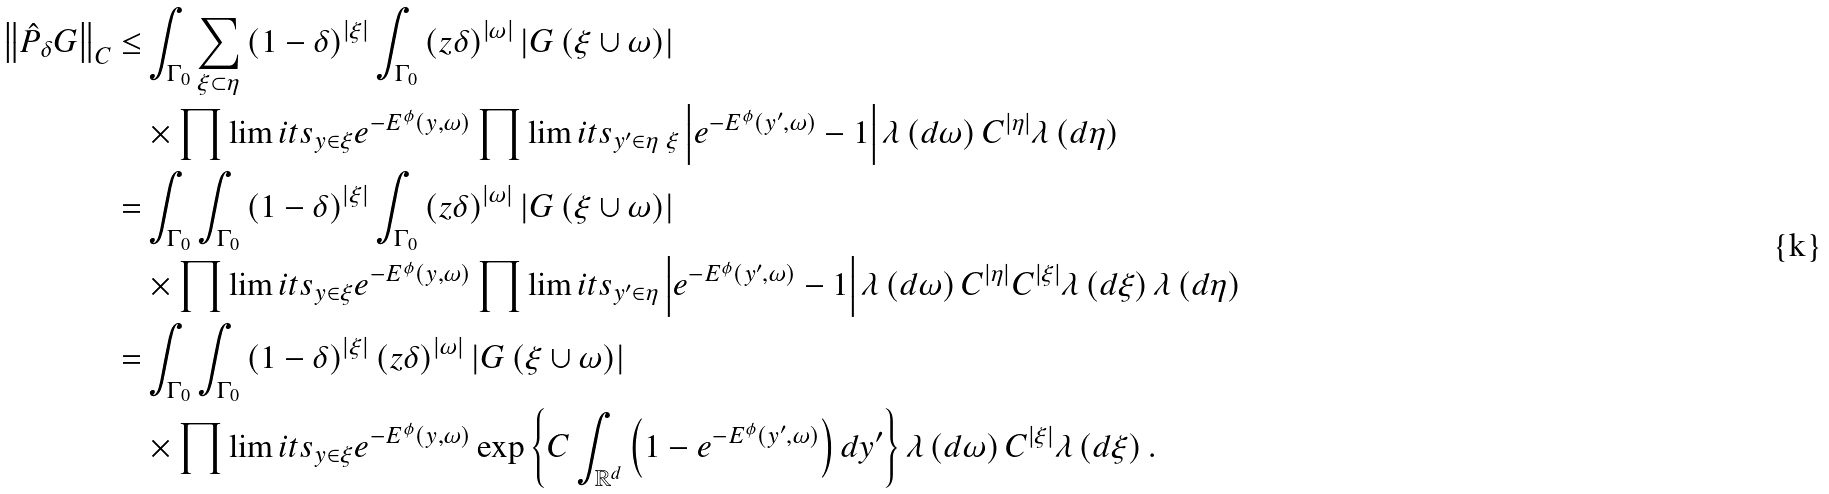Convert formula to latex. <formula><loc_0><loc_0><loc_500><loc_500>\left \| \hat { P } _ { \delta } G \right \| _ { C } \leq & \int _ { \Gamma _ { 0 } } \sum _ { \xi \subset \eta } \left ( 1 - \delta \right ) ^ { \left | \xi \right | } \int _ { \Gamma _ { 0 } } \left ( z \delta \right ) ^ { \left | \omega \right | } \left | G \left ( \xi \cup \omega \right ) \right | \\ & \times \prod \lim i t s _ { y \in \xi } e ^ { - E ^ { \phi } \left ( y , \omega \right ) } \prod \lim i t s _ { y ^ { \prime } \in \eta \ \xi } \left | e ^ { - E ^ { \phi } \left ( y ^ { \prime } , \omega \right ) } - 1 \right | \lambda \left ( d \omega \right ) C ^ { \left | \eta \right | } \lambda \left ( d \eta \right ) \\ = & \int _ { \Gamma _ { 0 } } \int _ { \Gamma _ { 0 } } \left ( 1 - \delta \right ) ^ { \left | \xi \right | } \int _ { \Gamma _ { 0 } } \left ( z \delta \right ) ^ { \left | \omega \right | } \left | G \left ( \xi \cup \omega \right ) \right | \\ & \times \prod \lim i t s _ { y \in \xi } e ^ { - E ^ { \phi } \left ( y , \omega \right ) } \prod \lim i t s _ { y ^ { \prime } \in \eta } \left | e ^ { - E ^ { \phi } \left ( y ^ { \prime } , \omega \right ) } - 1 \right | \lambda \left ( d \omega \right ) C ^ { \left | \eta \right | } C ^ { \left | \xi \right | } \lambda \left ( d \xi \right ) \lambda \left ( d \eta \right ) \\ = & \int _ { \Gamma _ { 0 } } \int _ { \Gamma _ { 0 } } \left ( 1 - \delta \right ) ^ { \left | \xi \right | } \left ( z \delta \right ) ^ { \left | \omega \right | } \left | G \left ( \xi \cup \omega \right ) \right | \\ & \times \prod \lim i t s _ { y \in \xi } e ^ { - E ^ { \phi } \left ( y , \omega \right ) } \exp \left \{ C \int _ { { { \mathbb { R } } ^ { d } } } \left ( 1 - e ^ { - E ^ { \phi } \left ( y ^ { \prime } , \omega \right ) } \right ) d y ^ { \prime } \right \} \lambda \left ( d \omega \right ) C ^ { \left | \xi \right | } \lambda \left ( d \xi \right ) .</formula> 